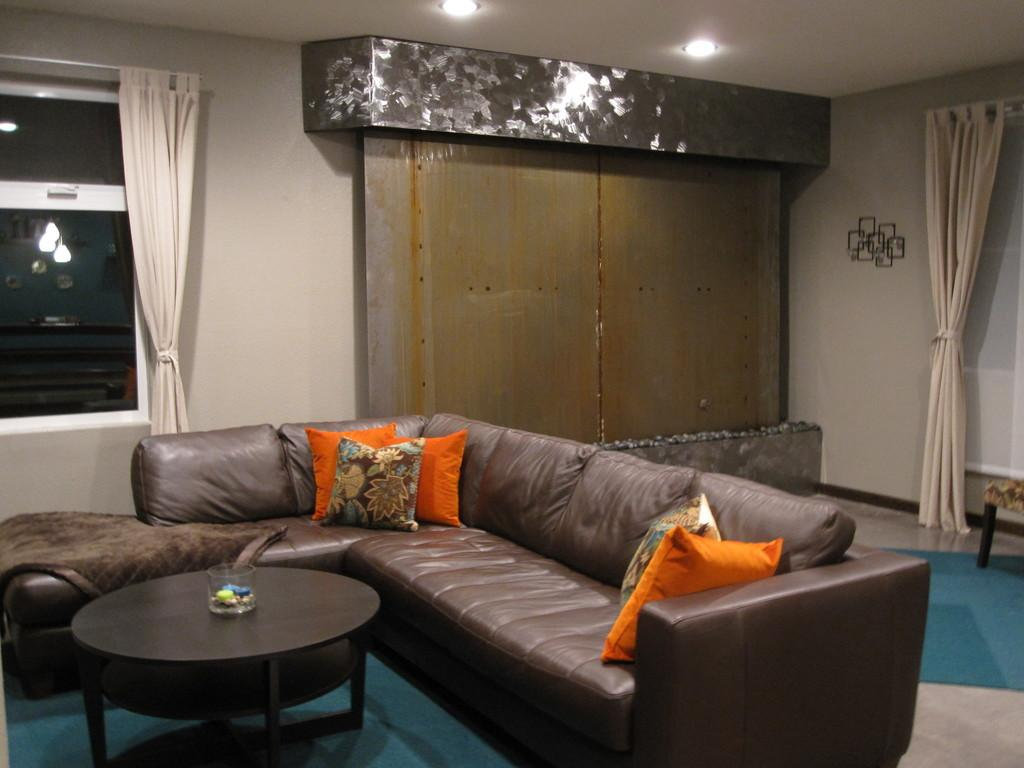What type of furniture is in the image? There is a brown sofa in the image. How many pillows are on the sofa? The sofa has five pillows on it. What is located in front of the sofa? There is a table in front of the sofa. What can be seen near the window in the image? The window has cream curtains attached to it. What type of toothpaste is on the table in the image? There is no toothpaste present in the image. What color is the death in the image? There is no reference to death in the image, so it is not possible to determine its color. 